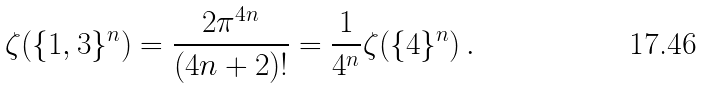Convert formula to latex. <formula><loc_0><loc_0><loc_500><loc_500>\zeta ( \{ 1 , 3 \} ^ { n } ) = \frac { 2 \pi ^ { 4 n } } { ( 4 n + 2 ) ! } = \frac { 1 } { 4 ^ { n } } \zeta ( \{ 4 \} ^ { n } ) \, .</formula> 